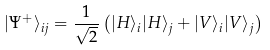Convert formula to latex. <formula><loc_0><loc_0><loc_500><loc_500>| \Psi ^ { + } \rangle _ { i j } = \frac { 1 } { \sqrt { 2 } } \left ( | H \rangle _ { i } | H \rangle _ { j } + | V \rangle _ { i } | V \rangle _ { j } \right )</formula> 